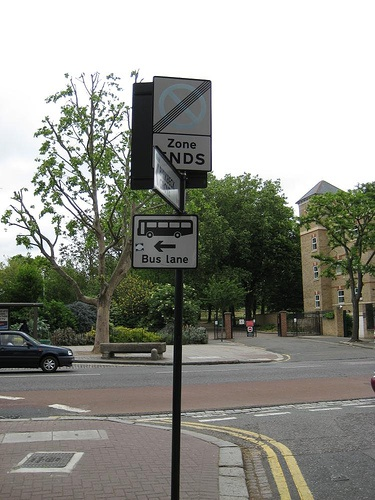Describe the objects in this image and their specific colors. I can see car in white, black, gray, and darkblue tones, bench in white, black, and gray tones, and car in white, black, gray, and maroon tones in this image. 